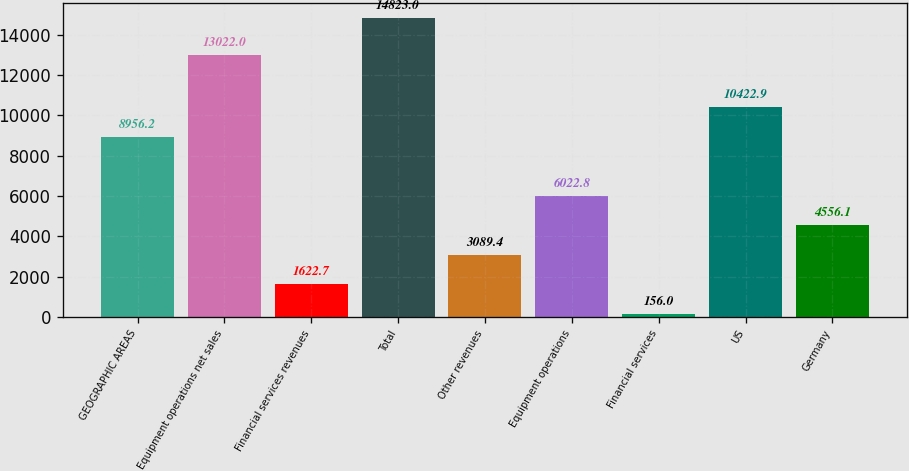<chart> <loc_0><loc_0><loc_500><loc_500><bar_chart><fcel>GEOGRAPHIC AREAS<fcel>Equipment operations net sales<fcel>Financial services revenues<fcel>Total<fcel>Other revenues<fcel>Equipment operations<fcel>Financial services<fcel>US<fcel>Germany<nl><fcel>8956.2<fcel>13022<fcel>1622.7<fcel>14823<fcel>3089.4<fcel>6022.8<fcel>156<fcel>10422.9<fcel>4556.1<nl></chart> 